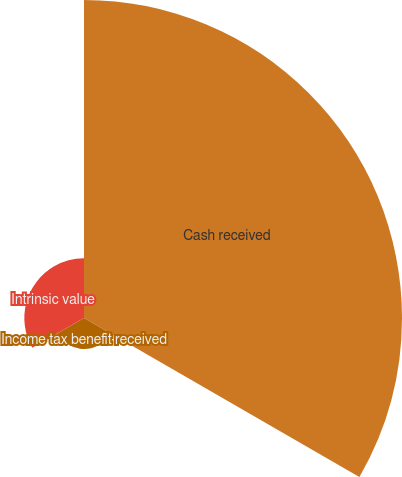Convert chart. <chart><loc_0><loc_0><loc_500><loc_500><pie_chart><fcel>Cash received<fcel>Income tax benefit received<fcel>Intrinsic value<nl><fcel>77.82%<fcel>7.58%<fcel>14.6%<nl></chart> 